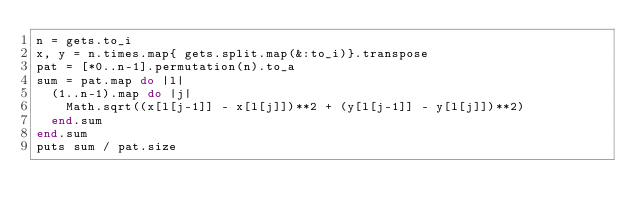Convert code to text. <code><loc_0><loc_0><loc_500><loc_500><_Ruby_>n = gets.to_i
x, y = n.times.map{ gets.split.map(&:to_i)}.transpose
pat = [*0..n-1].permutation(n).to_a
sum = pat.map do |l|
  (1..n-1).map do |j|
    Math.sqrt((x[l[j-1]] - x[l[j]])**2 + (y[l[j-1]] - y[l[j]])**2)
  end.sum
end.sum
puts sum / pat.size</code> 